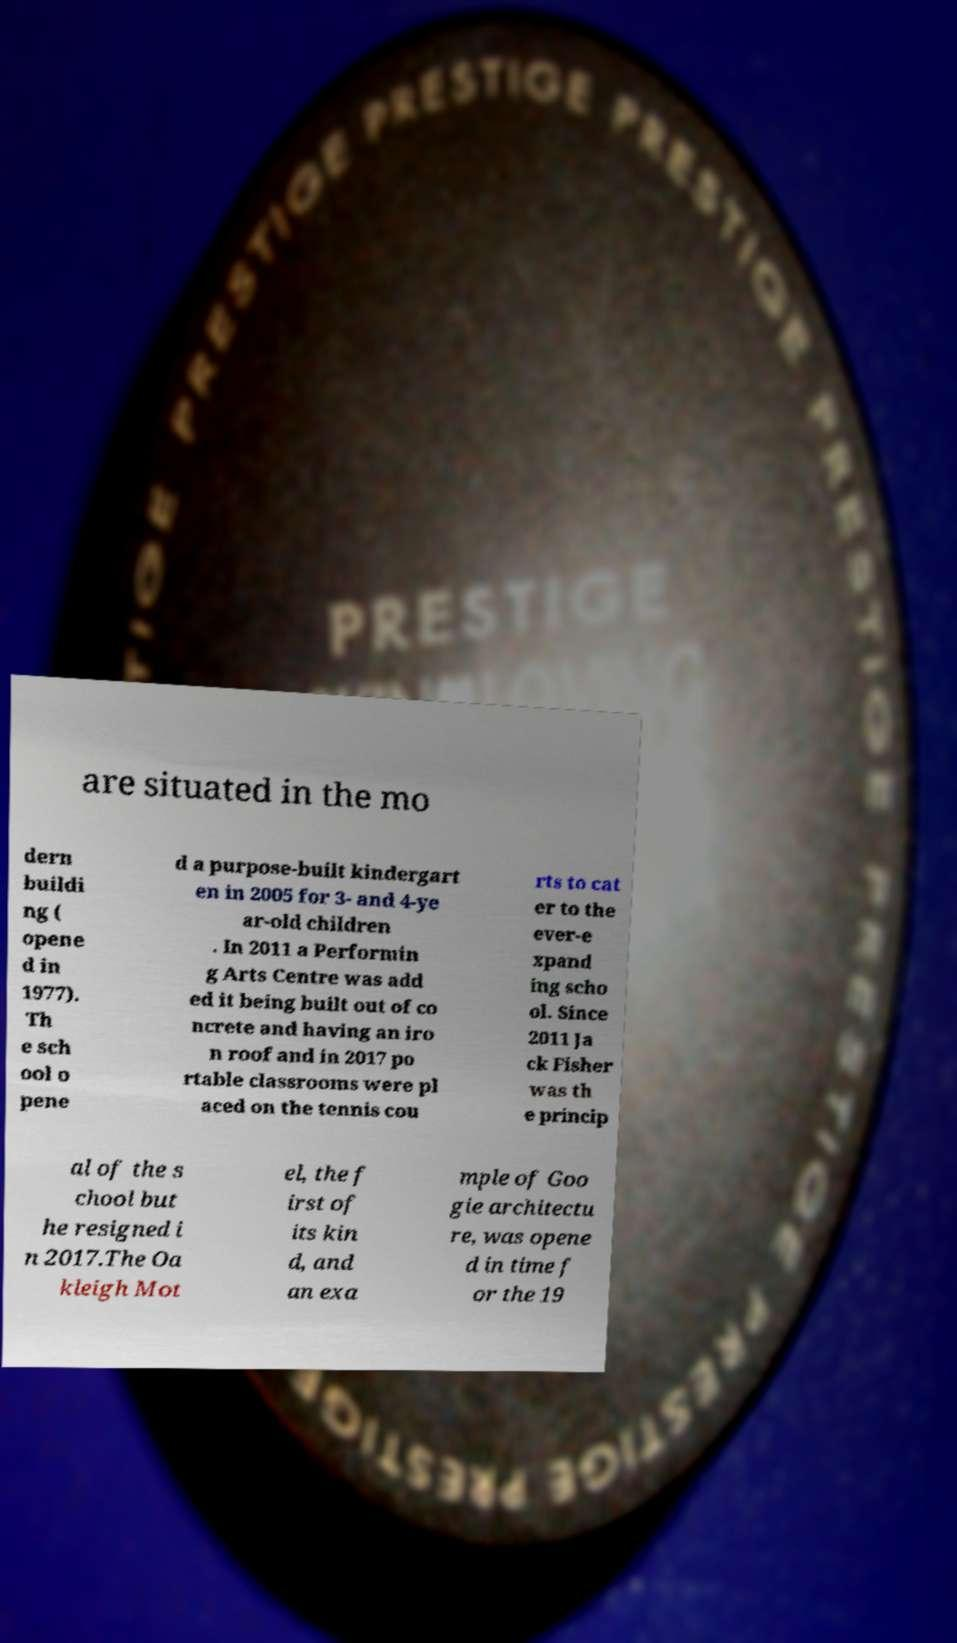Can you accurately transcribe the text from the provided image for me? are situated in the mo dern buildi ng ( opene d in 1977). Th e sch ool o pene d a purpose-built kindergart en in 2005 for 3- and 4-ye ar-old children . In 2011 a Performin g Arts Centre was add ed it being built out of co ncrete and having an iro n roof and in 2017 po rtable classrooms were pl aced on the tennis cou rts to cat er to the ever-e xpand ing scho ol. Since 2011 Ja ck Fisher was th e princip al of the s chool but he resigned i n 2017.The Oa kleigh Mot el, the f irst of its kin d, and an exa mple of Goo gie architectu re, was opene d in time f or the 19 